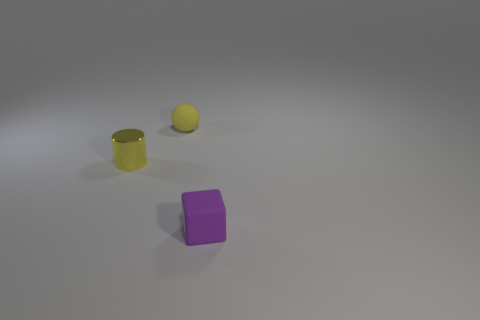There is a matte thing behind the small yellow object that is in front of the yellow matte ball; what is its size?
Give a very brief answer. Small. What number of small yellow things are there?
Provide a succinct answer. 2. There is a object to the left of the matte object that is behind the rubber object that is in front of the small shiny thing; what is its color?
Provide a short and direct response. Yellow. Is the number of green metallic balls less than the number of purple blocks?
Ensure brevity in your answer.  Yes. There is a small cube that is the same material as the yellow ball; what is its color?
Your answer should be very brief. Purple. How many metallic things are the same size as the cylinder?
Make the answer very short. 0. What material is the purple object?
Your answer should be compact. Rubber. Is the number of yellow metallic objects greater than the number of green cylinders?
Your answer should be compact. Yes. Is the shape of the tiny purple rubber thing the same as the yellow matte thing?
Keep it short and to the point. No. Is there anything else that is the same shape as the yellow matte object?
Offer a terse response. No. 